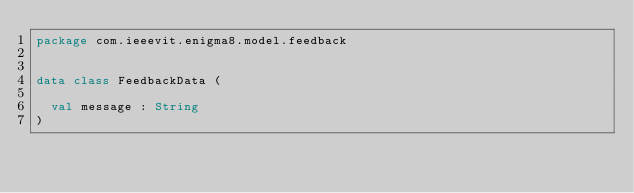<code> <loc_0><loc_0><loc_500><loc_500><_Kotlin_>package com.ieeevit.enigma8.model.feedback


data class FeedbackData (

	val message : String
)</code> 